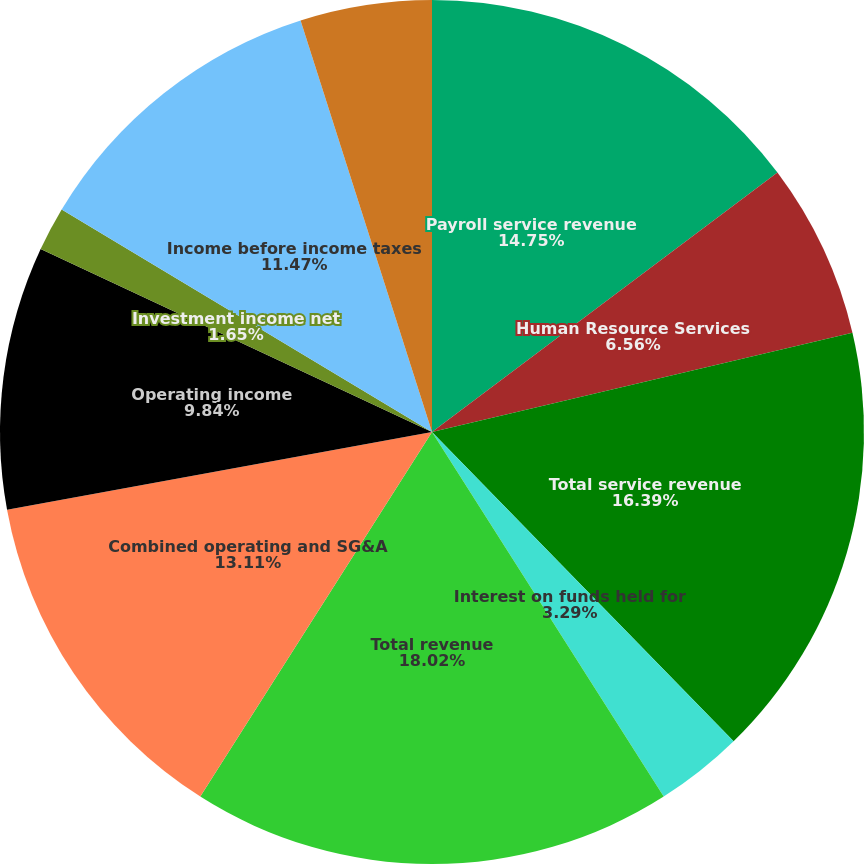<chart> <loc_0><loc_0><loc_500><loc_500><pie_chart><fcel>Payroll service revenue<fcel>Human Resource Services<fcel>Total service revenue<fcel>Interest on funds held for<fcel>Total revenue<fcel>Combined operating and SG&A<fcel>Operating income<fcel>Investment income net<fcel>Income before income taxes<fcel>Income taxes<nl><fcel>14.75%<fcel>6.56%<fcel>16.39%<fcel>3.29%<fcel>18.02%<fcel>13.11%<fcel>9.84%<fcel>1.65%<fcel>11.47%<fcel>4.92%<nl></chart> 